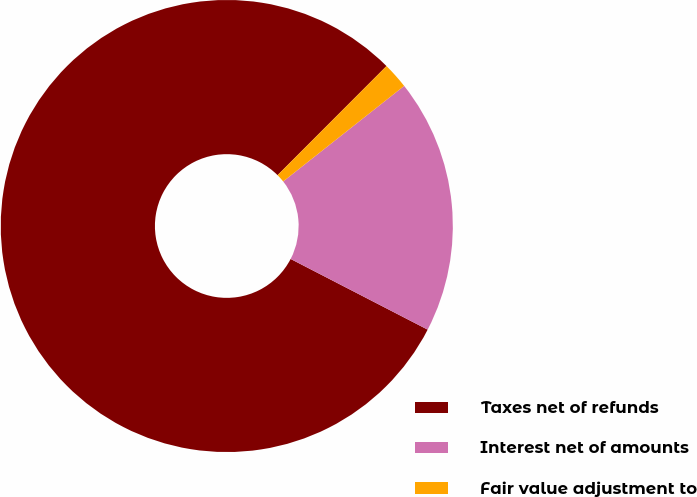Convert chart to OTSL. <chart><loc_0><loc_0><loc_500><loc_500><pie_chart><fcel>Taxes net of refunds<fcel>Interest net of amounts<fcel>Fair value adjustment to<nl><fcel>79.91%<fcel>18.22%<fcel>1.87%<nl></chart> 